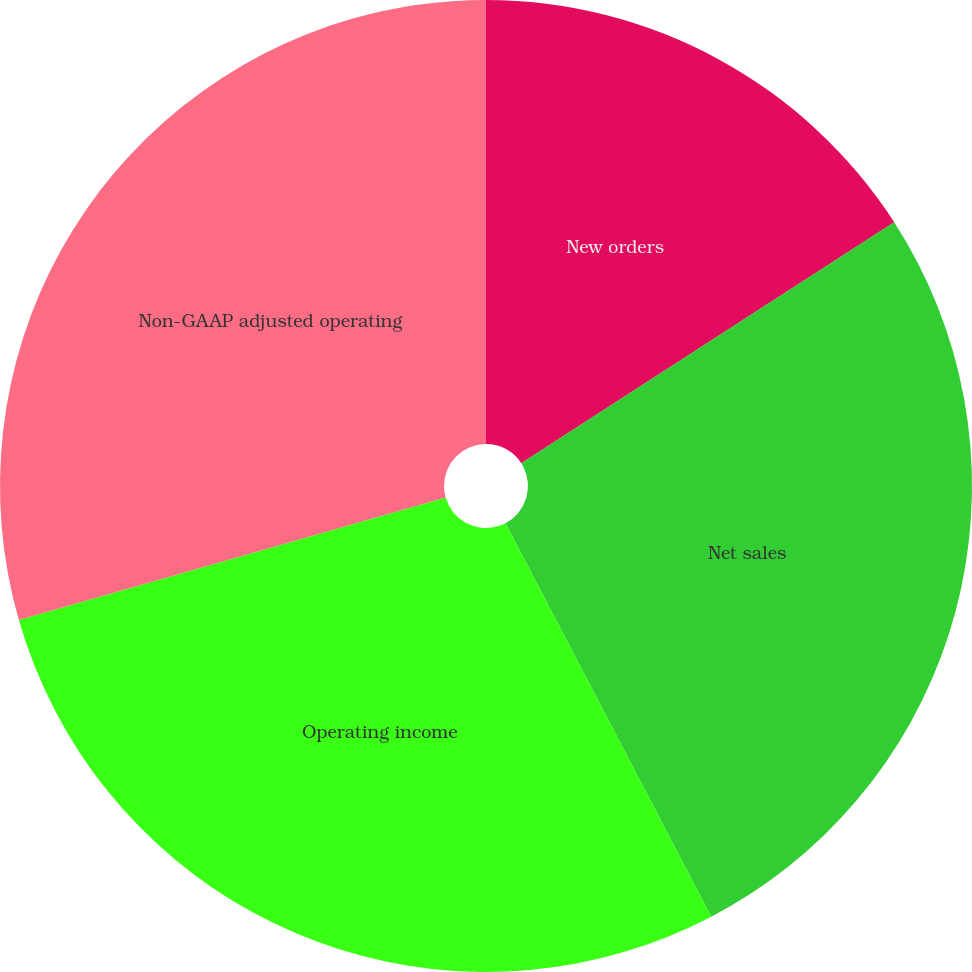<chart> <loc_0><loc_0><loc_500><loc_500><pie_chart><fcel>New orders<fcel>Net sales<fcel>Operating income<fcel>Non-GAAP adjusted operating<nl><fcel>15.87%<fcel>26.46%<fcel>28.22%<fcel>29.45%<nl></chart> 